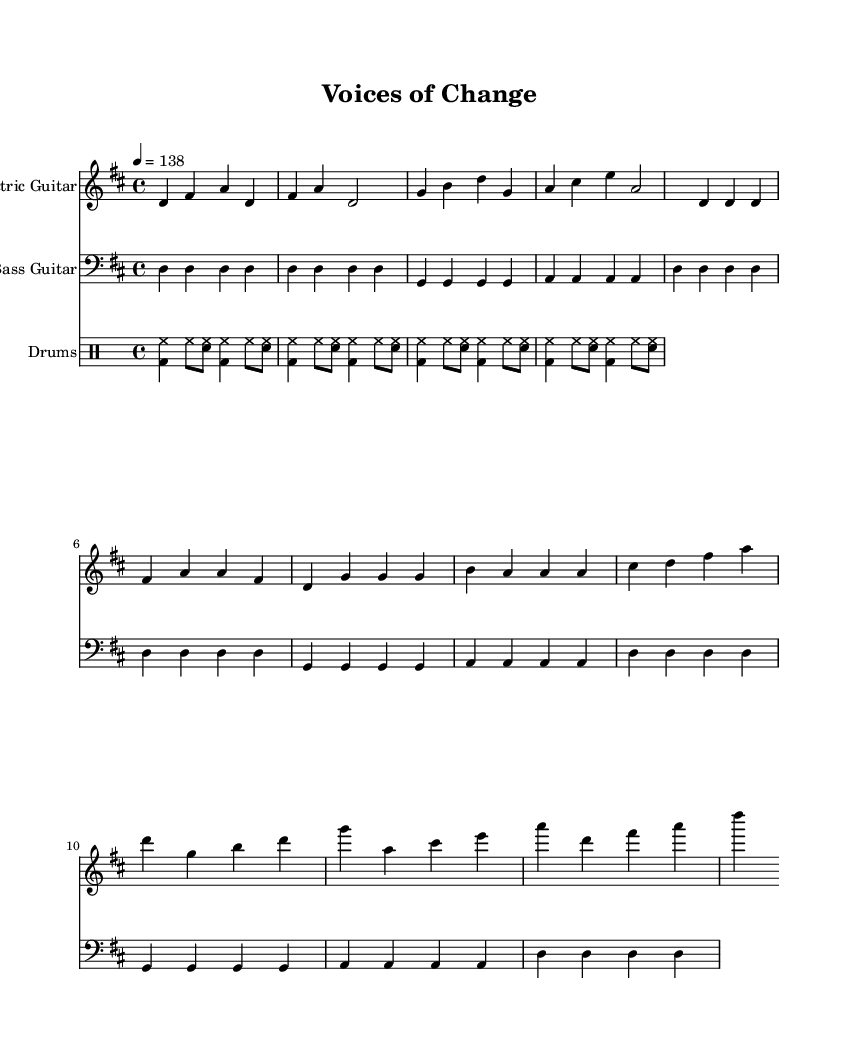What is the key signature of this music? The key signature is D major, indicated by the presence of two sharps (F# and C#) in the score.
Answer: D major What is the time signature of this music? The time signature is 4/4, which means there are four beats in each measure and the quarter note gets one beat. This is shown at the beginning of the score.
Answer: 4/4 What is the tempo marking of this music? The tempo marking indicates that the music is played at a speed of 138 beats per minute, which is noted in the tempo instruction at the beginning of the score.
Answer: 138 How many measures are in the introductory section? The introductory section consists of four measures, as indicated by the notation provided before the verse starts.
Answer: Four What is the rhythmic pattern used in the drums part? The drums part employs a basic rock beat with kick drum (bd), snare drum (sn), and hi-hat (hh) patterns that alternate consistently, typical of the rock music style.
Answer: Basic rock beat Which instruments are included in this score? The score includes three instruments: electric guitar, bass guitar, and drums. This is evident from the three distinct staves that are provided for each instrument.
Answer: Electric guitar, bass guitar, and drums What is the primary mood conveyed by this music? The music captures an energetic and passionate mood, often associated with grassroots political movements, characterized by its driving tempo and strong rhythmic sections.
Answer: Energetic and passionate 